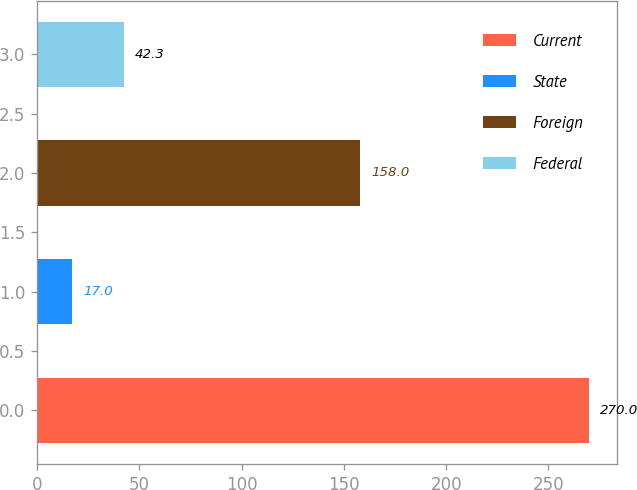Convert chart. <chart><loc_0><loc_0><loc_500><loc_500><bar_chart><fcel>Current<fcel>State<fcel>Foreign<fcel>Federal<nl><fcel>270<fcel>17<fcel>158<fcel>42.3<nl></chart> 